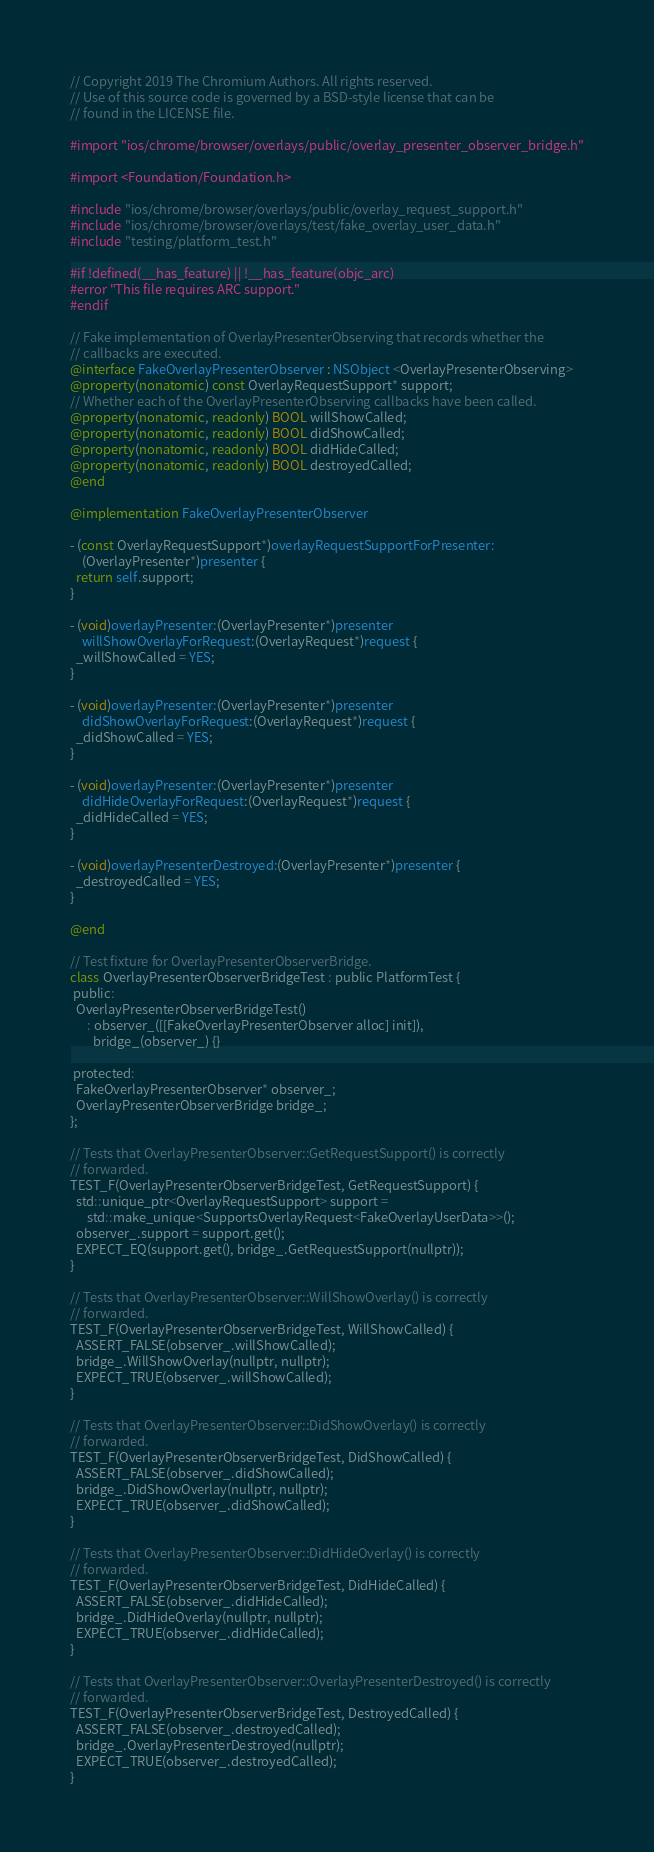Convert code to text. <code><loc_0><loc_0><loc_500><loc_500><_ObjectiveC_>// Copyright 2019 The Chromium Authors. All rights reserved.
// Use of this source code is governed by a BSD-style license that can be
// found in the LICENSE file.

#import "ios/chrome/browser/overlays/public/overlay_presenter_observer_bridge.h"

#import <Foundation/Foundation.h>

#include "ios/chrome/browser/overlays/public/overlay_request_support.h"
#include "ios/chrome/browser/overlays/test/fake_overlay_user_data.h"
#include "testing/platform_test.h"

#if !defined(__has_feature) || !__has_feature(objc_arc)
#error "This file requires ARC support."
#endif

// Fake implementation of OverlayPresenterObserving that records whether the
// callbacks are executed.
@interface FakeOverlayPresenterObserver : NSObject <OverlayPresenterObserving>
@property(nonatomic) const OverlayRequestSupport* support;
// Whether each of the OverlayPresenterObserving callbacks have been called.
@property(nonatomic, readonly) BOOL willShowCalled;
@property(nonatomic, readonly) BOOL didShowCalled;
@property(nonatomic, readonly) BOOL didHideCalled;
@property(nonatomic, readonly) BOOL destroyedCalled;
@end

@implementation FakeOverlayPresenterObserver

- (const OverlayRequestSupport*)overlayRequestSupportForPresenter:
    (OverlayPresenter*)presenter {
  return self.support;
}

- (void)overlayPresenter:(OverlayPresenter*)presenter
    willShowOverlayForRequest:(OverlayRequest*)request {
  _willShowCalled = YES;
}

- (void)overlayPresenter:(OverlayPresenter*)presenter
    didShowOverlayForRequest:(OverlayRequest*)request {
  _didShowCalled = YES;
}

- (void)overlayPresenter:(OverlayPresenter*)presenter
    didHideOverlayForRequest:(OverlayRequest*)request {
  _didHideCalled = YES;
}

- (void)overlayPresenterDestroyed:(OverlayPresenter*)presenter {
  _destroyedCalled = YES;
}

@end

// Test fixture for OverlayPresenterObserverBridge.
class OverlayPresenterObserverBridgeTest : public PlatformTest {
 public:
  OverlayPresenterObserverBridgeTest()
      : observer_([[FakeOverlayPresenterObserver alloc] init]),
        bridge_(observer_) {}

 protected:
  FakeOverlayPresenterObserver* observer_;
  OverlayPresenterObserverBridge bridge_;
};

// Tests that OverlayPresenterObserver::GetRequestSupport() is correctly
// forwarded.
TEST_F(OverlayPresenterObserverBridgeTest, GetRequestSupport) {
  std::unique_ptr<OverlayRequestSupport> support =
      std::make_unique<SupportsOverlayRequest<FakeOverlayUserData>>();
  observer_.support = support.get();
  EXPECT_EQ(support.get(), bridge_.GetRequestSupport(nullptr));
}

// Tests that OverlayPresenterObserver::WillShowOverlay() is correctly
// forwarded.
TEST_F(OverlayPresenterObserverBridgeTest, WillShowCalled) {
  ASSERT_FALSE(observer_.willShowCalled);
  bridge_.WillShowOverlay(nullptr, nullptr);
  EXPECT_TRUE(observer_.willShowCalled);
}

// Tests that OverlayPresenterObserver::DidShowOverlay() is correctly
// forwarded.
TEST_F(OverlayPresenterObserverBridgeTest, DidShowCalled) {
  ASSERT_FALSE(observer_.didShowCalled);
  bridge_.DidShowOverlay(nullptr, nullptr);
  EXPECT_TRUE(observer_.didShowCalled);
}

// Tests that OverlayPresenterObserver::DidHideOverlay() is correctly
// forwarded.
TEST_F(OverlayPresenterObserverBridgeTest, DidHideCalled) {
  ASSERT_FALSE(observer_.didHideCalled);
  bridge_.DidHideOverlay(nullptr, nullptr);
  EXPECT_TRUE(observer_.didHideCalled);
}

// Tests that OverlayPresenterObserver::OverlayPresenterDestroyed() is correctly
// forwarded.
TEST_F(OverlayPresenterObserverBridgeTest, DestroyedCalled) {
  ASSERT_FALSE(observer_.destroyedCalled);
  bridge_.OverlayPresenterDestroyed(nullptr);
  EXPECT_TRUE(observer_.destroyedCalled);
}
</code> 